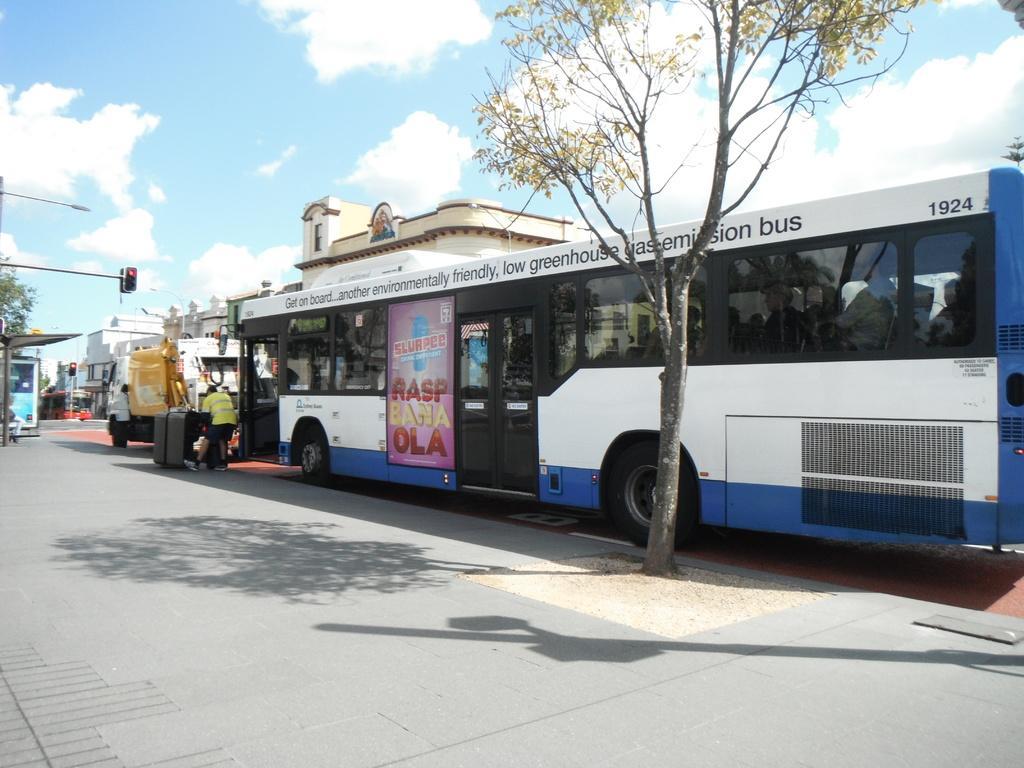In one or two sentences, can you explain what this image depicts? In this image we can see a bus and a truck on the road. We can also see a person standing on the pathway, some trees, a person sitting under a roof, some buildings, the traffic signal, a street pole and the sky which looks cloudy. 